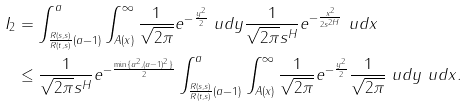Convert formula to latex. <formula><loc_0><loc_0><loc_500><loc_500>I _ { 2 } & = \int _ { \frac { R ( s , s ) } { R ( t , s ) } ( a - 1 ) } ^ { a } \int _ { A ( x ) } ^ { \infty } \frac { 1 } { \sqrt { 2 \pi } } e ^ { - \frac { y ^ { 2 } } { 2 } } \ u d y \frac { 1 } { \sqrt { 2 \pi } s ^ { H } } e ^ { - \frac { x ^ { 2 } } { 2 s ^ { 2 H } } } \ u d x \\ & \leq \frac { 1 } { \sqrt { 2 \pi } s ^ { H } } e ^ { - \frac { \min \{ a ^ { 2 } , ( a - 1 ) ^ { 2 } \} } { 2 } } \int _ { \frac { R ( s , s ) } { R ( t , s ) } ( a - 1 ) } ^ { a } \int _ { A ( x ) } ^ { \infty } \frac { 1 } { \sqrt { 2 \pi } } e ^ { - \frac { y ^ { 2 } } { 2 } } \frac { 1 } { \sqrt { 2 \pi } } \ u d y \ u d x .</formula> 